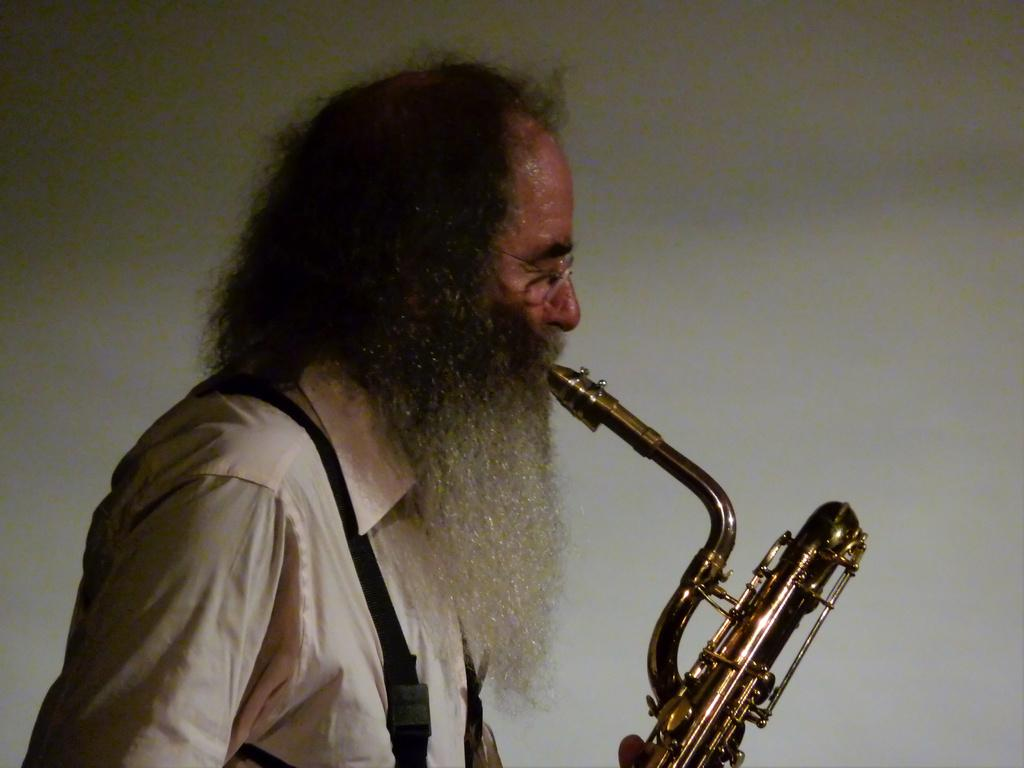What is the main subject of the image? There is a person in the image. What object is the person holding? The person is holding a saxophone in the image. What can be seen in the background of the image? There is a wall in the background of the image. What type of snail can be seen crawling on the wall in the image? There is no snail present in the image; only a person holding a saxophone and a wall in the background are visible. 